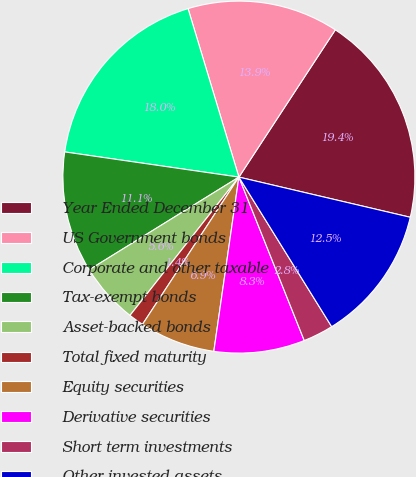Convert chart to OTSL. <chart><loc_0><loc_0><loc_500><loc_500><pie_chart><fcel>Year Ended December 31<fcel>US Government bonds<fcel>Corporate and other taxable<fcel>Tax-exempt bonds<fcel>Asset-backed bonds<fcel>Total fixed maturity<fcel>Equity securities<fcel>Derivative securities<fcel>Short term investments<fcel>Other invested assets<nl><fcel>19.44%<fcel>13.89%<fcel>18.05%<fcel>11.11%<fcel>5.56%<fcel>1.39%<fcel>6.95%<fcel>8.33%<fcel>2.78%<fcel>12.5%<nl></chart> 